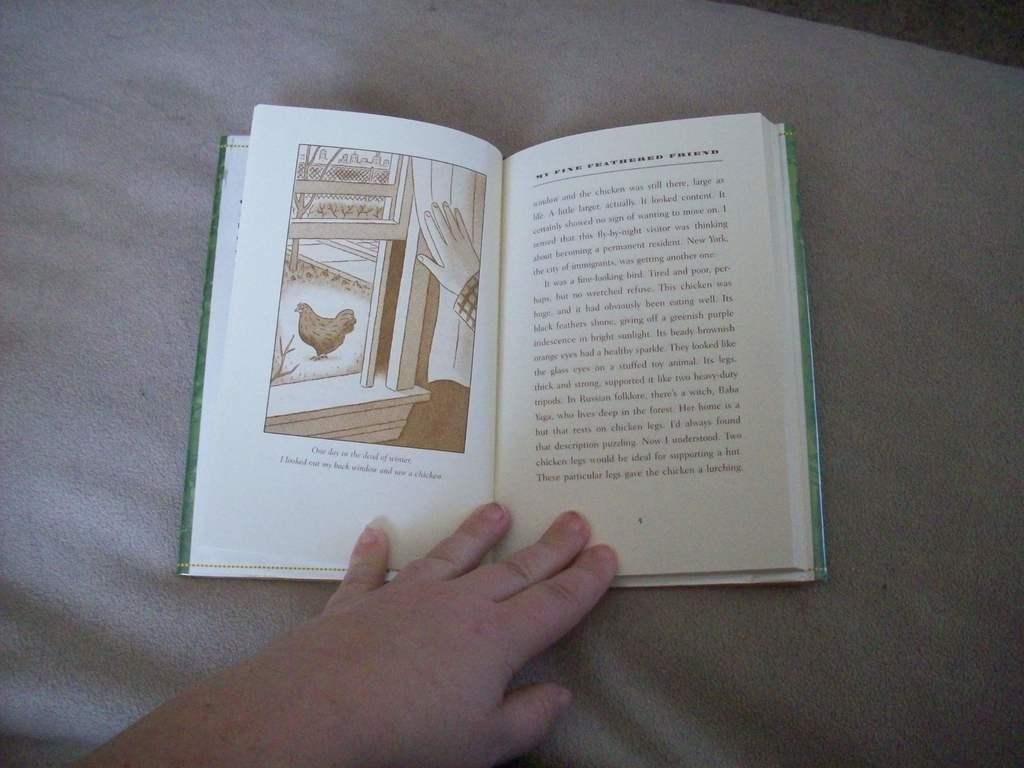Provide a one-sentence caption for the provided image. A person holds a book open to a chapter called My Fine Feathered Friend. 